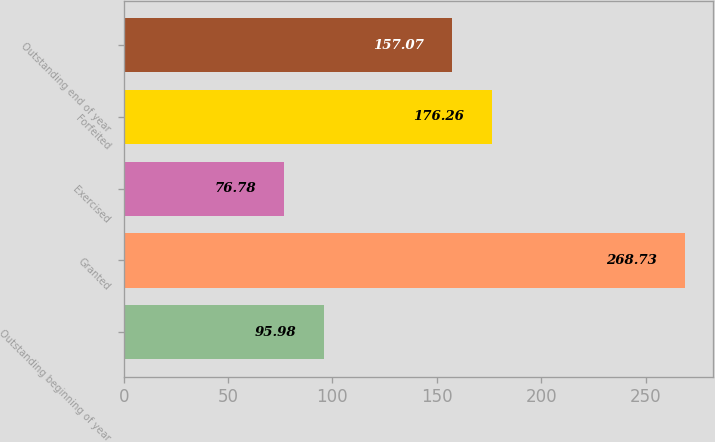Convert chart. <chart><loc_0><loc_0><loc_500><loc_500><bar_chart><fcel>Outstanding beginning of year<fcel>Granted<fcel>Exercised<fcel>Forfeited<fcel>Outstanding end of year<nl><fcel>95.98<fcel>268.73<fcel>76.78<fcel>176.26<fcel>157.07<nl></chart> 